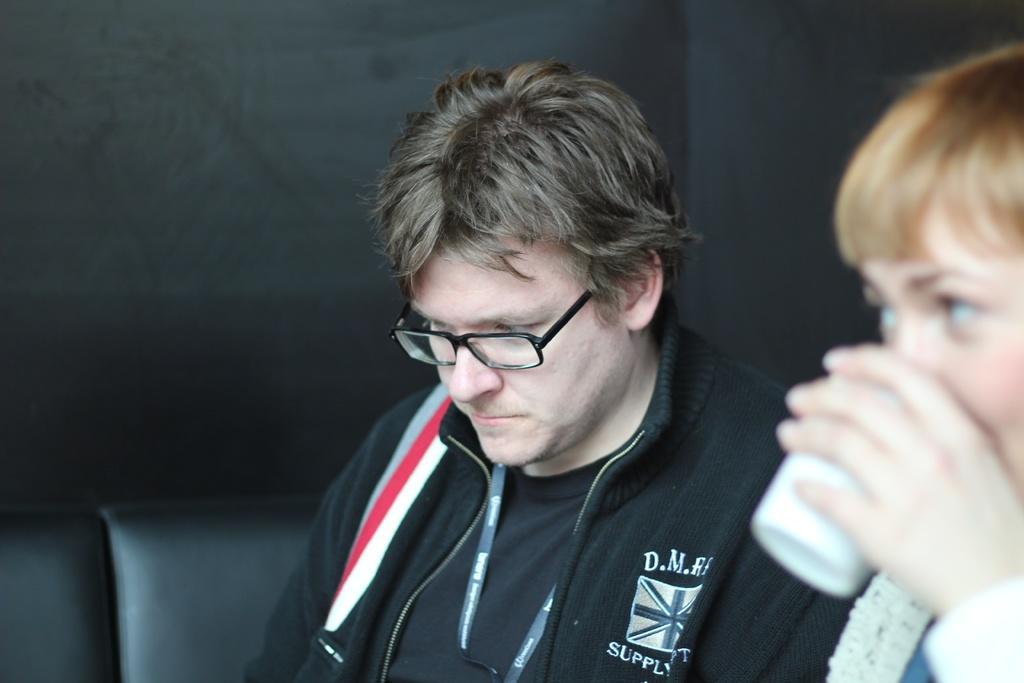How would you summarize this image in a sentence or two? In this image I can see a person wearing a black dress and spectacles. There is a person on the right, holding a glass. There is a black background. 